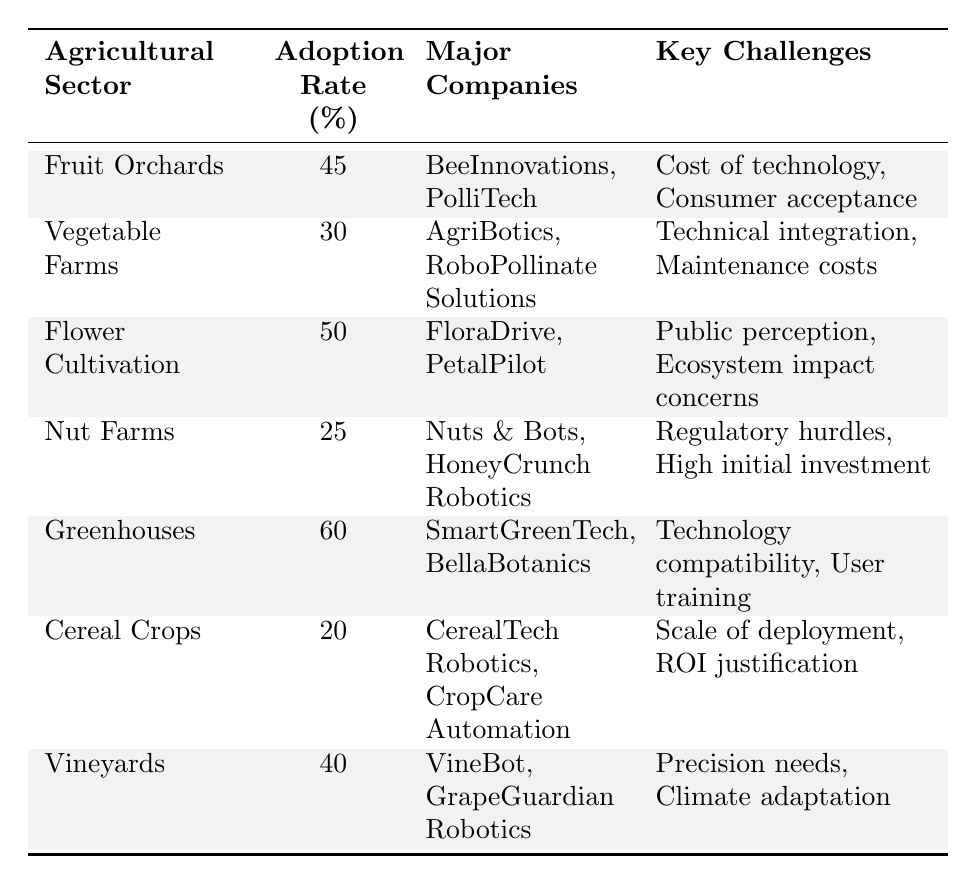What is the adoption rate percentage for Greenhouses? The table shows that the adoption rate for Greenhouses is directly listed, which is 60%.
Answer: 60 Which agricultural sector has the highest adoption rate? By comparing the adoption rates in the table, Greenhouses have the highest rate at 60%.
Answer: Greenhouses How many major companies are involved in Nut Farms? The table lists two major companies involved in Nut Farms: Nuts & Bots and HoneyCrunch Robotics.
Answer: 2 What are the key challenges faced by Flower Cultivation? The table indicates that the challenges for Flower Cultivation are public perception and ecosystem impact concerns.
Answer: Public perception, ecosystem impact concerns What is the average adoption rate percentage across all agricultural sectors? To calculate the average, the adoption rates of all sectors are summed (45 + 30 + 50 + 25 + 60 + 20 + 40 = 270), then divided by the number of sectors (7), which gives 270/7 ≈ 38.57.
Answer: Approximately 38.57 Do Vegetable Farms have a lower adoption rate than Nut Farms? Comparing the adoption rates, Vegetable Farms have a rate of 30%, while Nut Farms have a rate of 25%. Therefore, Vegetable Farms have a higher rate.
Answer: No Which sector faces regulatory hurdles as a challenge? The table states that Nut Farms face regulatory hurdles as one of their key challenges.
Answer: Nut Farms What is the difference in adoption rates between Greenhouses and Cereal Crops? The adoption rate for Greenhouses is 60% and for Cereal Crops, it is 20%. The difference is calculated as 60 - 20 = 40.
Answer: 40 Are BeeInnovations and PolliTech the major companies involved in Flower Cultivation? The table specifies that FloralDrive and PetalPilot are the major companies involved in Flower Cultivation, not BeeInnovations and PolliTech.
Answer: No What is the total number of challenges faced by all sectors combined? Each sector has its own challenges, and by counting them from the table: 2 (Fruit Orchards) + 2 (Vegetable Farms) + 2 (Flower Cultivation) + 2 (Nut Farms) + 2 (Greenhouses) + 2 (Cereal Crops) + 2 (Vineyards) = 14 total challenges faced.
Answer: 14 Which two agricultural sectors have an adoption rate below 30%? By reviewing the table, Cereal Crops (20%) and Nut Farms (25%) have adoption rates below 30%.
Answer: Cereal Crops and Nut Farms 